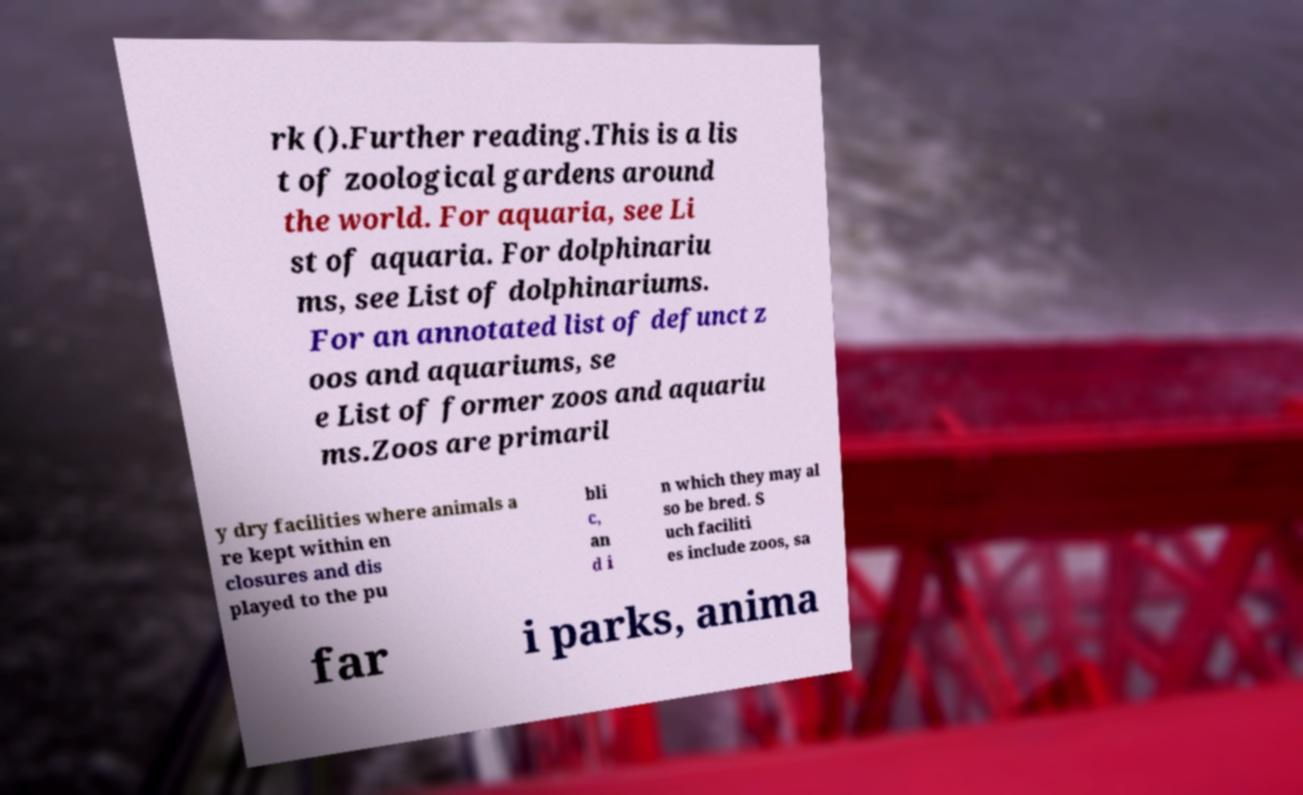Could you assist in decoding the text presented in this image and type it out clearly? rk ().Further reading.This is a lis t of zoological gardens around the world. For aquaria, see Li st of aquaria. For dolphinariu ms, see List of dolphinariums. For an annotated list of defunct z oos and aquariums, se e List of former zoos and aquariu ms.Zoos are primaril y dry facilities where animals a re kept within en closures and dis played to the pu bli c, an d i n which they may al so be bred. S uch faciliti es include zoos, sa far i parks, anima 